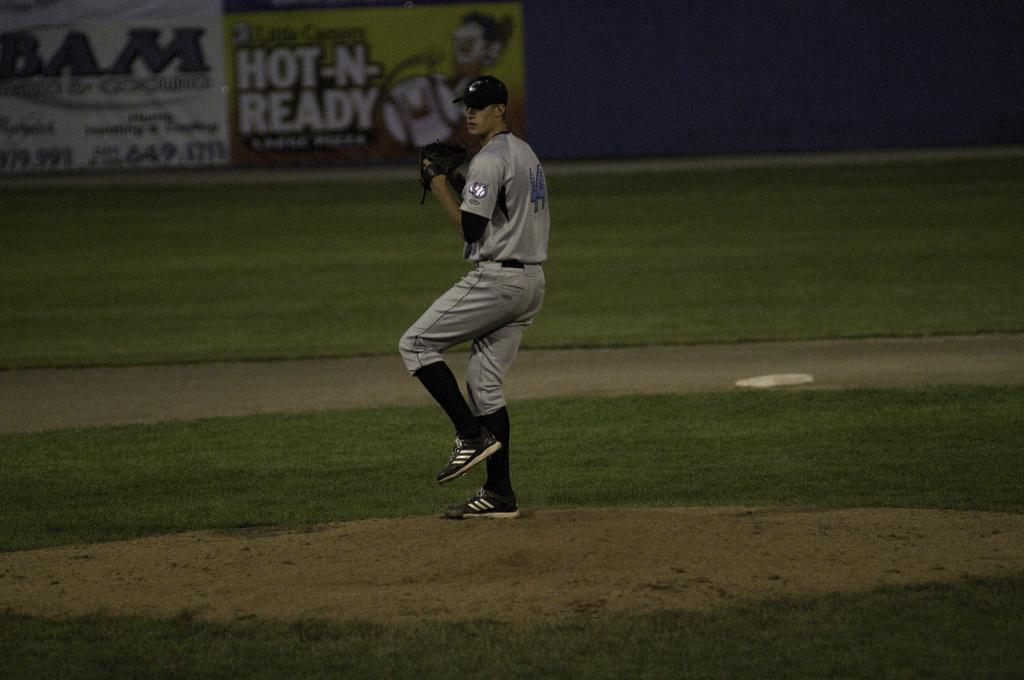What is the man in the image doing? The provided facts do not specify what the man is doing, but he is standing in the image. What type of headwear is the man wearing? The man is wearing a cap in the image. What type of handwear is the man wearing? The man is wearing gloves in the image. What type of surface is visible in the image? Soil and grass are visible on the floor in the image. What type of brass instrument is the man playing in the image? There is no brass instrument present in the image; the man is wearing gloves and standing on soil and grass. 